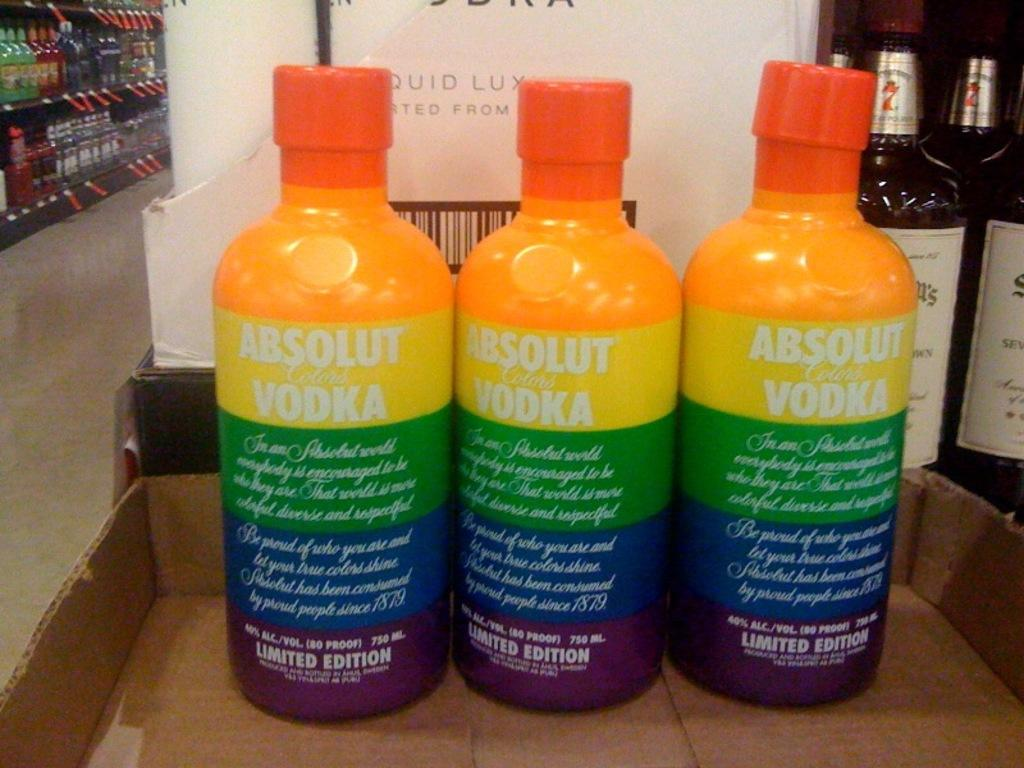<image>
Give a short and clear explanation of the subsequent image. Three bottles of absolut vodka in rainbow bottles. 